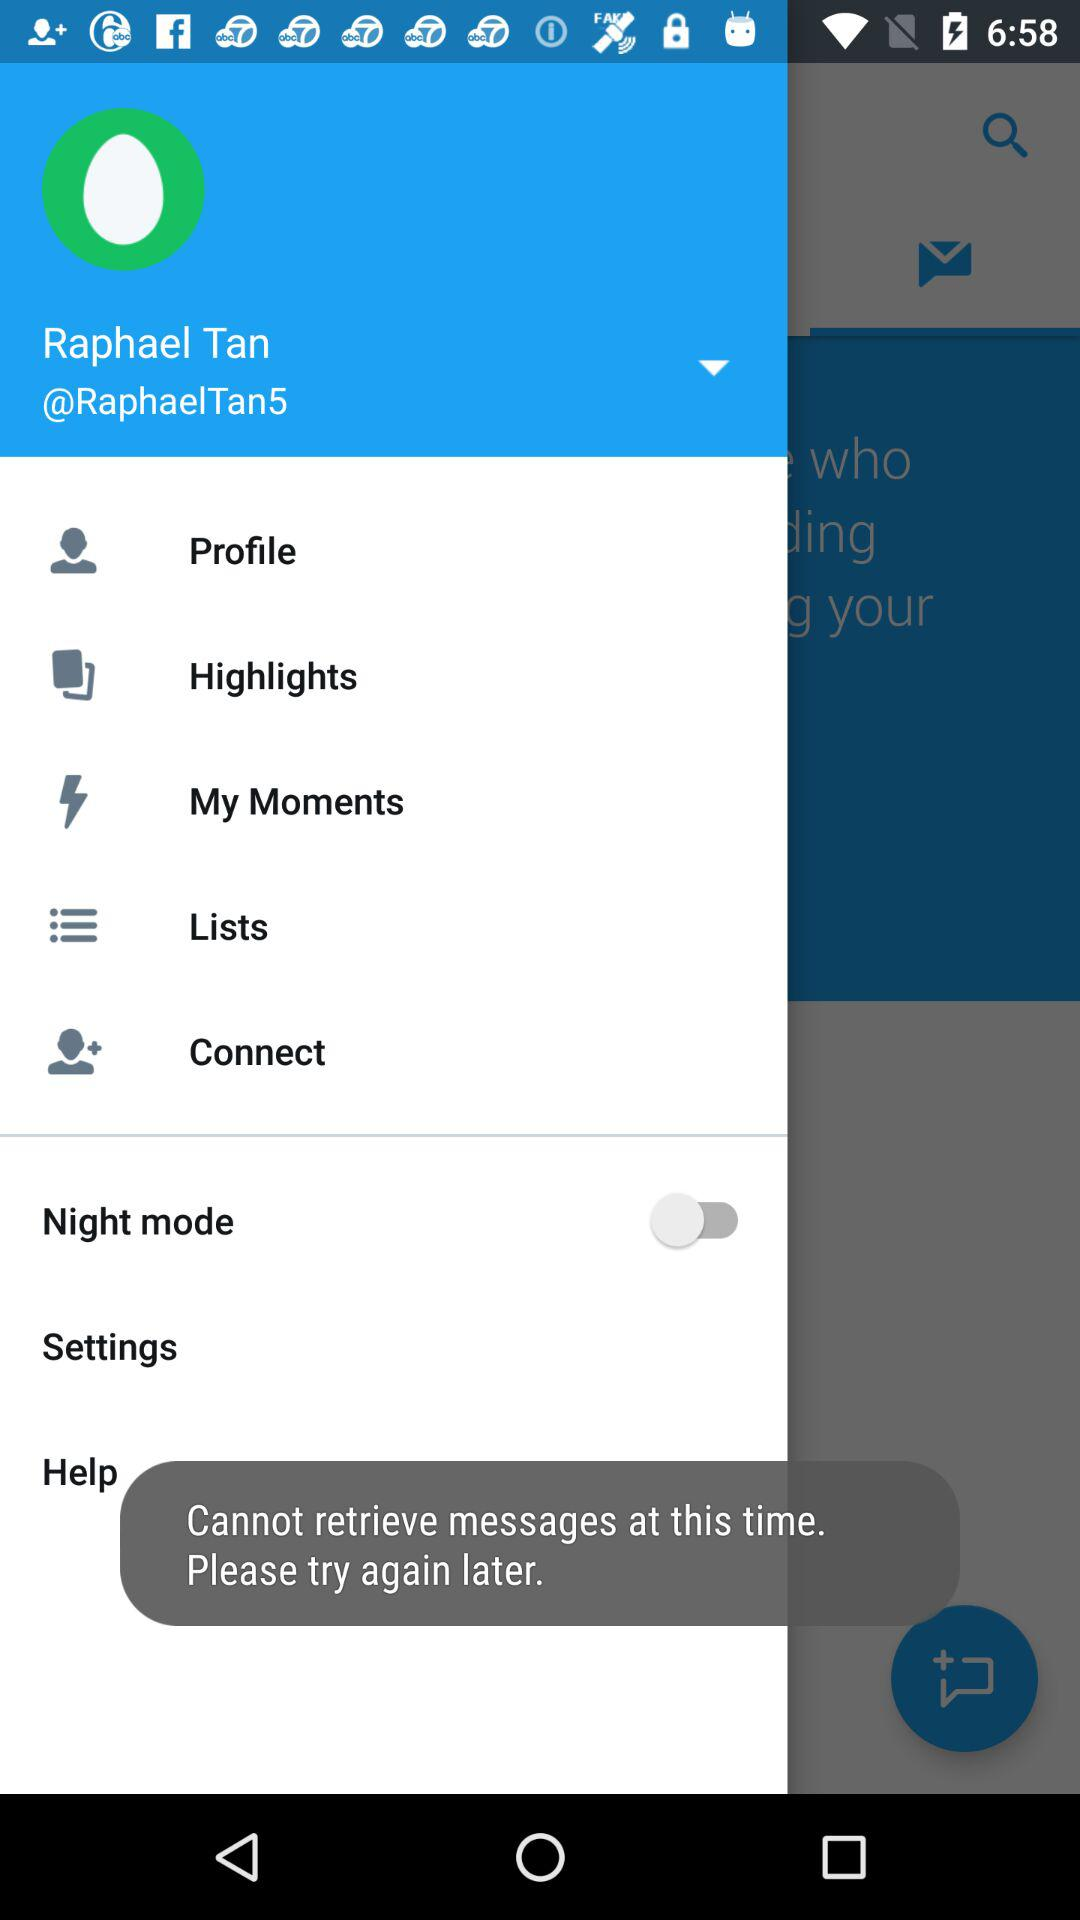What is the status of "Night mode"? The status is "off". 